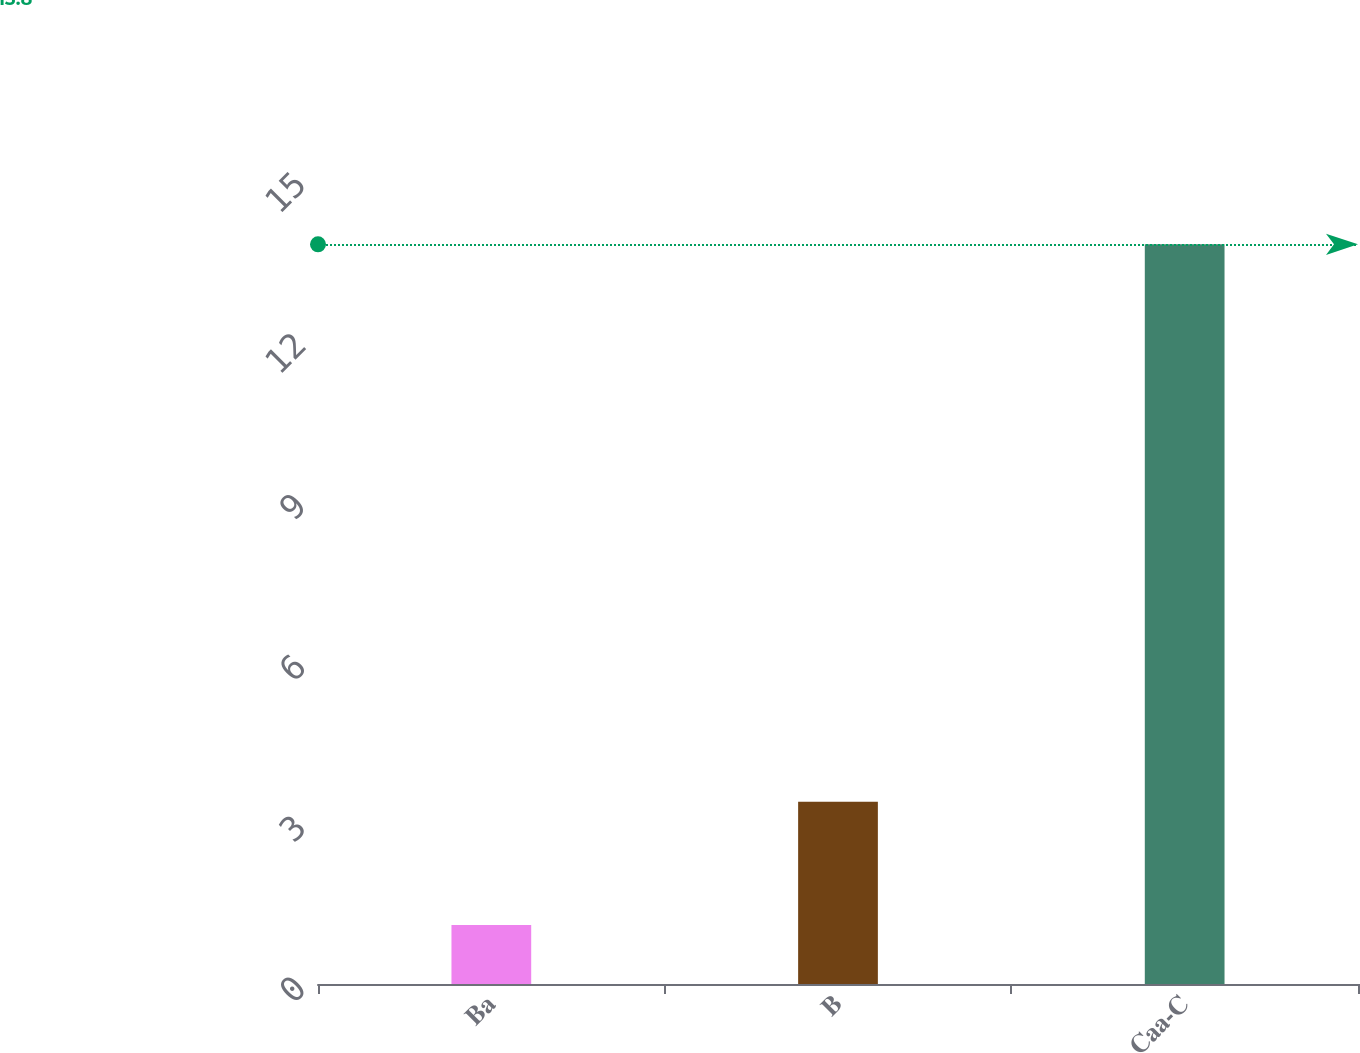Convert chart. <chart><loc_0><loc_0><loc_500><loc_500><bar_chart><fcel>Ba<fcel>B<fcel>Caa-C<nl><fcel>1.1<fcel>3.4<fcel>13.8<nl></chart> 